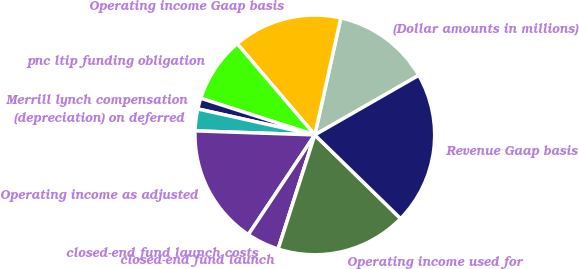<chart> <loc_0><loc_0><loc_500><loc_500><pie_chart><fcel>(Dollar amounts in millions)<fcel>Operating income Gaap basis<fcel>pnc ltip funding obligation<fcel>Merrill lynch compensation<fcel>(depreciation) on deferred<fcel>Operating income as adjusted<fcel>closed-end fund launch costs<fcel>closed-end fund launch<fcel>Operating income used for<fcel>Revenue Gaap basis<nl><fcel>13.23%<fcel>14.7%<fcel>8.82%<fcel>1.47%<fcel>2.94%<fcel>16.17%<fcel>4.41%<fcel>0.0%<fcel>17.64%<fcel>20.58%<nl></chart> 